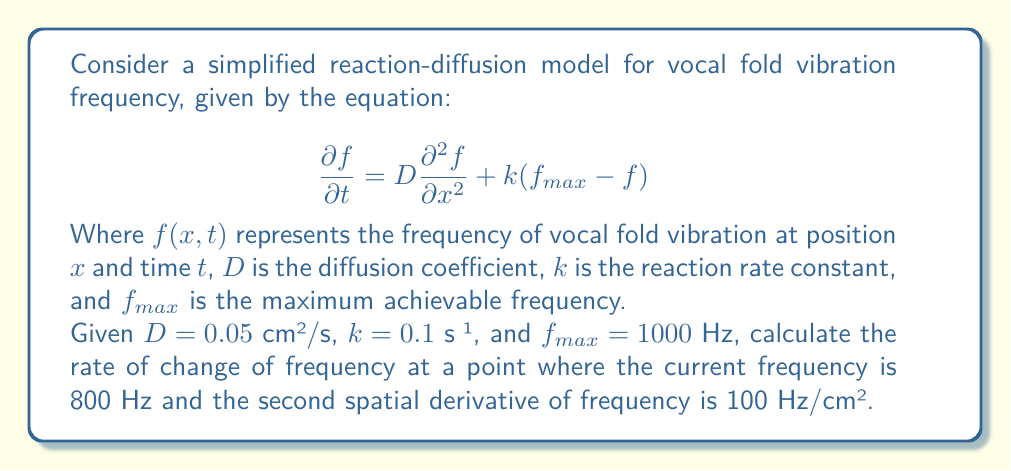Teach me how to tackle this problem. To solve this problem, we need to use the given reaction-diffusion equation and substitute the known values. Let's break it down step by step:

1. The reaction-diffusion equation is:
   $$\frac{\partial f}{\partial t} = D\frac{\partial^2 f}{\partial x^2} + k(f_{max} - f)$$

2. We are given the following values:
   - $D = 0.05$ cm²/s
   - $k = 0.1$ s⁻¹
   - $f_{max} = 1000$ Hz
   - Current frequency $f = 800$ Hz
   - Second spatial derivative $\frac{\partial^2 f}{\partial x^2} = 100$ Hz/cm²

3. Let's substitute these values into the equation:
   $$\frac{\partial f}{\partial t} = (0.05 \text{ cm²/s})(100 \text{ Hz/cm²}) + (0.1 \text{ s}^{-1})(1000 \text{ Hz} - 800 \text{ Hz})$$

4. Simplify the right-hand side:
   $$\frac{\partial f}{\partial t} = 5 \text{ Hz/s} + (0.1 \text{ s}^{-1})(200 \text{ Hz})$$

5. Calculate the second term:
   $$\frac{\partial f}{\partial t} = 5 \text{ Hz/s} + 20 \text{ Hz/s}$$

6. Sum up the terms:
   $$\frac{\partial f}{\partial t} = 25 \text{ Hz/s}$$

Thus, the rate of change of frequency at the given point is 25 Hz/s.
Answer: $25 \text{ Hz/s}$ 